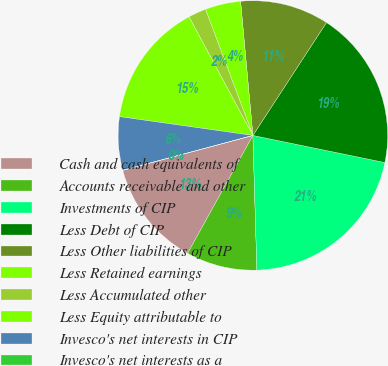Convert chart to OTSL. <chart><loc_0><loc_0><loc_500><loc_500><pie_chart><fcel>Cash and cash equivalents of<fcel>Accounts receivable and other<fcel>Investments of CIP<fcel>Less Debt of CIP<fcel>Less Other liabilities of CIP<fcel>Less Retained earnings<fcel>Less Accumulated other<fcel>Less Equity attributable to<fcel>Invesco's net interests in CIP<fcel>Invesco's net interests as a<nl><fcel>12.78%<fcel>8.52%<fcel>21.3%<fcel>19.03%<fcel>10.65%<fcel>4.26%<fcel>2.14%<fcel>14.91%<fcel>6.39%<fcel>0.01%<nl></chart> 